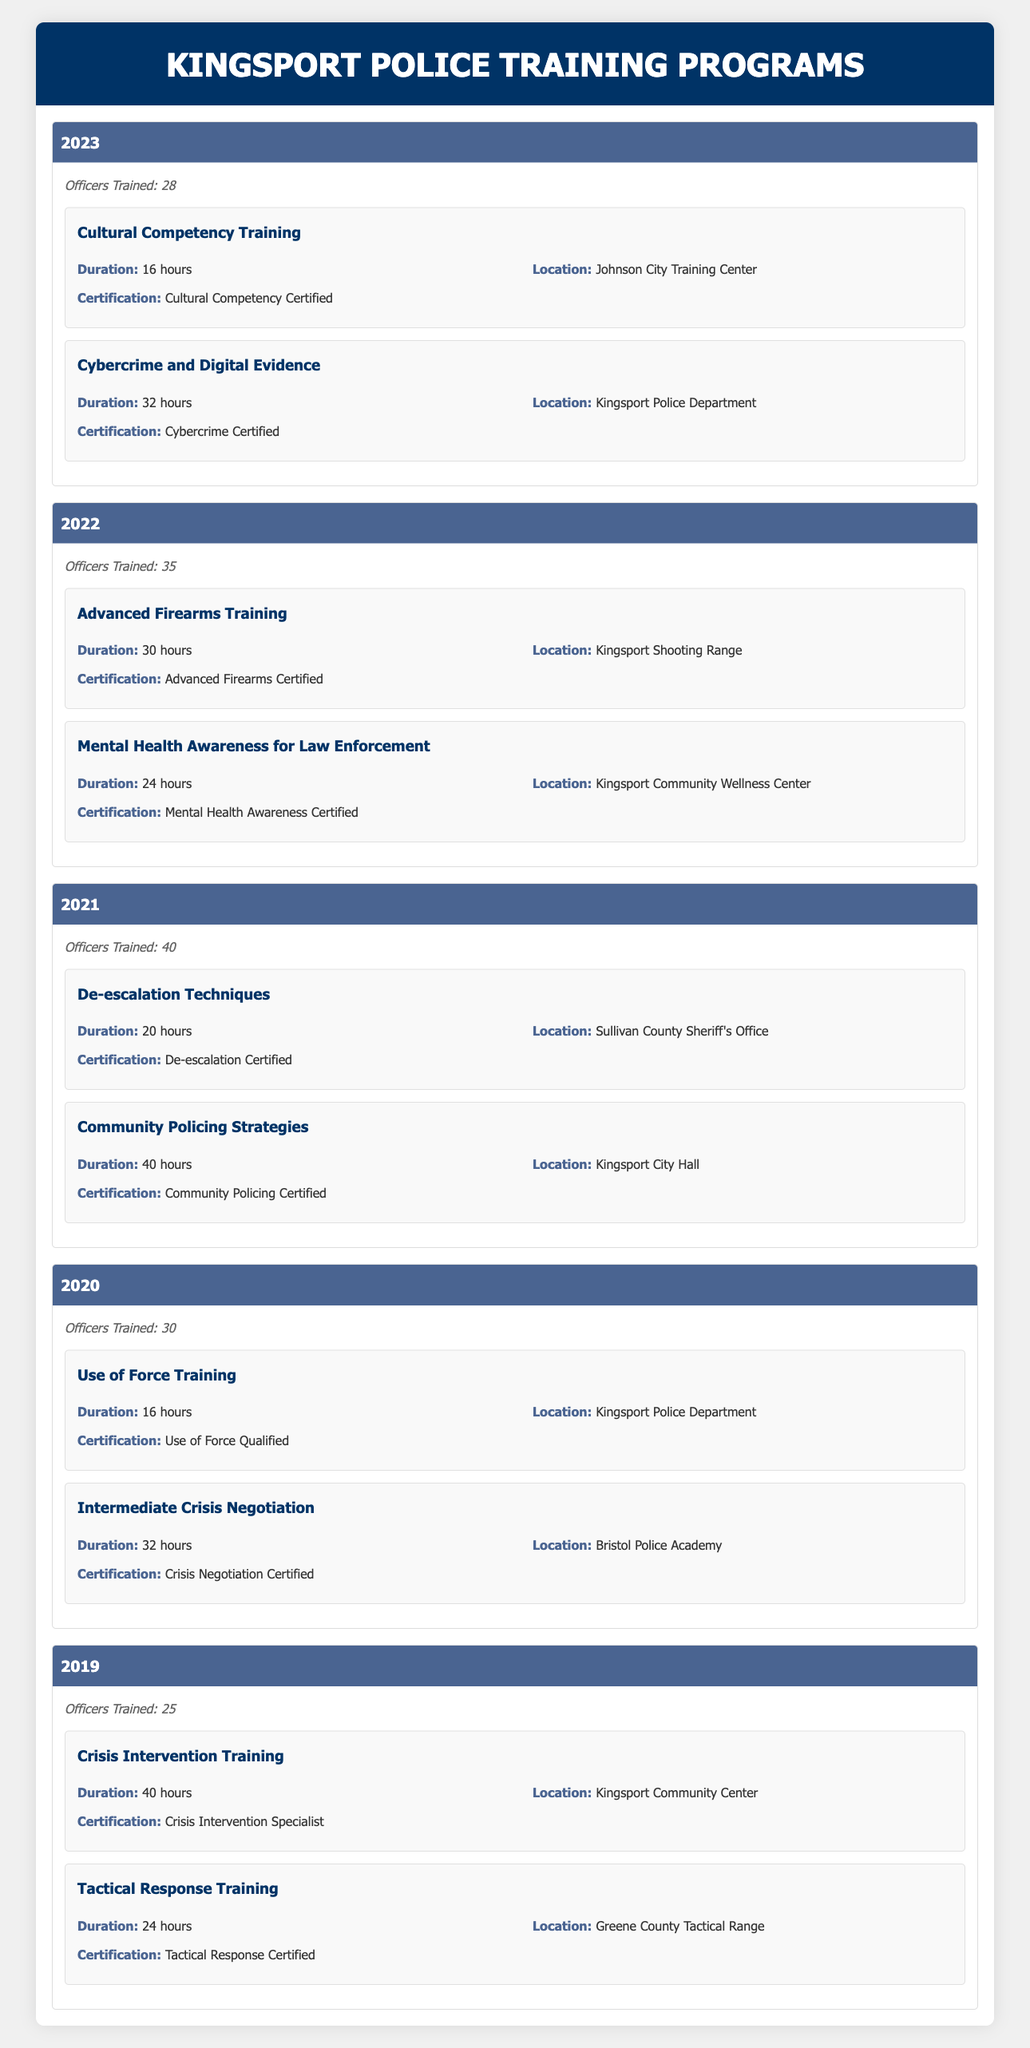What was the total number of officers trained in 2021? In 2021, the table states that 40 officers were trained.
Answer: 40 Which program had the longest duration in 2022? The longest duration program in 2022 is "Advanced Firearms Training," which lasted for 30 hours, compared to "Mental Health Awareness for Law Enforcement," which lasted for 24 hours.
Answer: Advanced Firearms Training How many officers were trained in 2019 and 2023 combined? In 2019, 25 officers were trained, and in 2023, 28 officers were trained. Thus, the total number of officers trained in both years is 25 + 28 = 53.
Answer: 53 Did all officers trained in 2020 receive a certification? Yes, both programs attended in 2020 ("Use of Force Training" and "Intermediate Crisis Negotiation") included certifications; therefore, all trained officers received a certification.
Answer: Yes What is the average number of officers trained per year over the five years? We will sum the officers trained across all five years: 25 (2019) + 30 (2020) + 40 (2021) + 35 (2022) + 28 (2023) = 158. We then divide by 5 years, resulting in an average of 158 / 5 = 31.6.
Answer: 31.6 Which location hosted the "Crisis Intervention Training"? According to the table, "Crisis Intervention Training" was held at the Kingsport Community Center.
Answer: Kingsport Community Center How many different programs certifying "Crisis Negotiation Certified" were offered between 2020 and 2022? The only program certifying "Crisis Negotiation Certified" during this period was the "Intermediate Crisis Negotiation" in 2020; thus, there is just one such program offered.
Answer: 1 Which year had the highest number of officers trained? The highest number of officers trained was 40 in 2021; all other years had fewer officers trained: 25 (2019), 30 (2020), 35 (2022), and 28 (2023).
Answer: 2021 What percentage of the total officers trained in five years was trained in 2021? The total number of officers trained over five years is 158. Since 40 were trained in 2021, the percentage is (40/158) * 100, which is approximately 25.32%.
Answer: 25.32% 